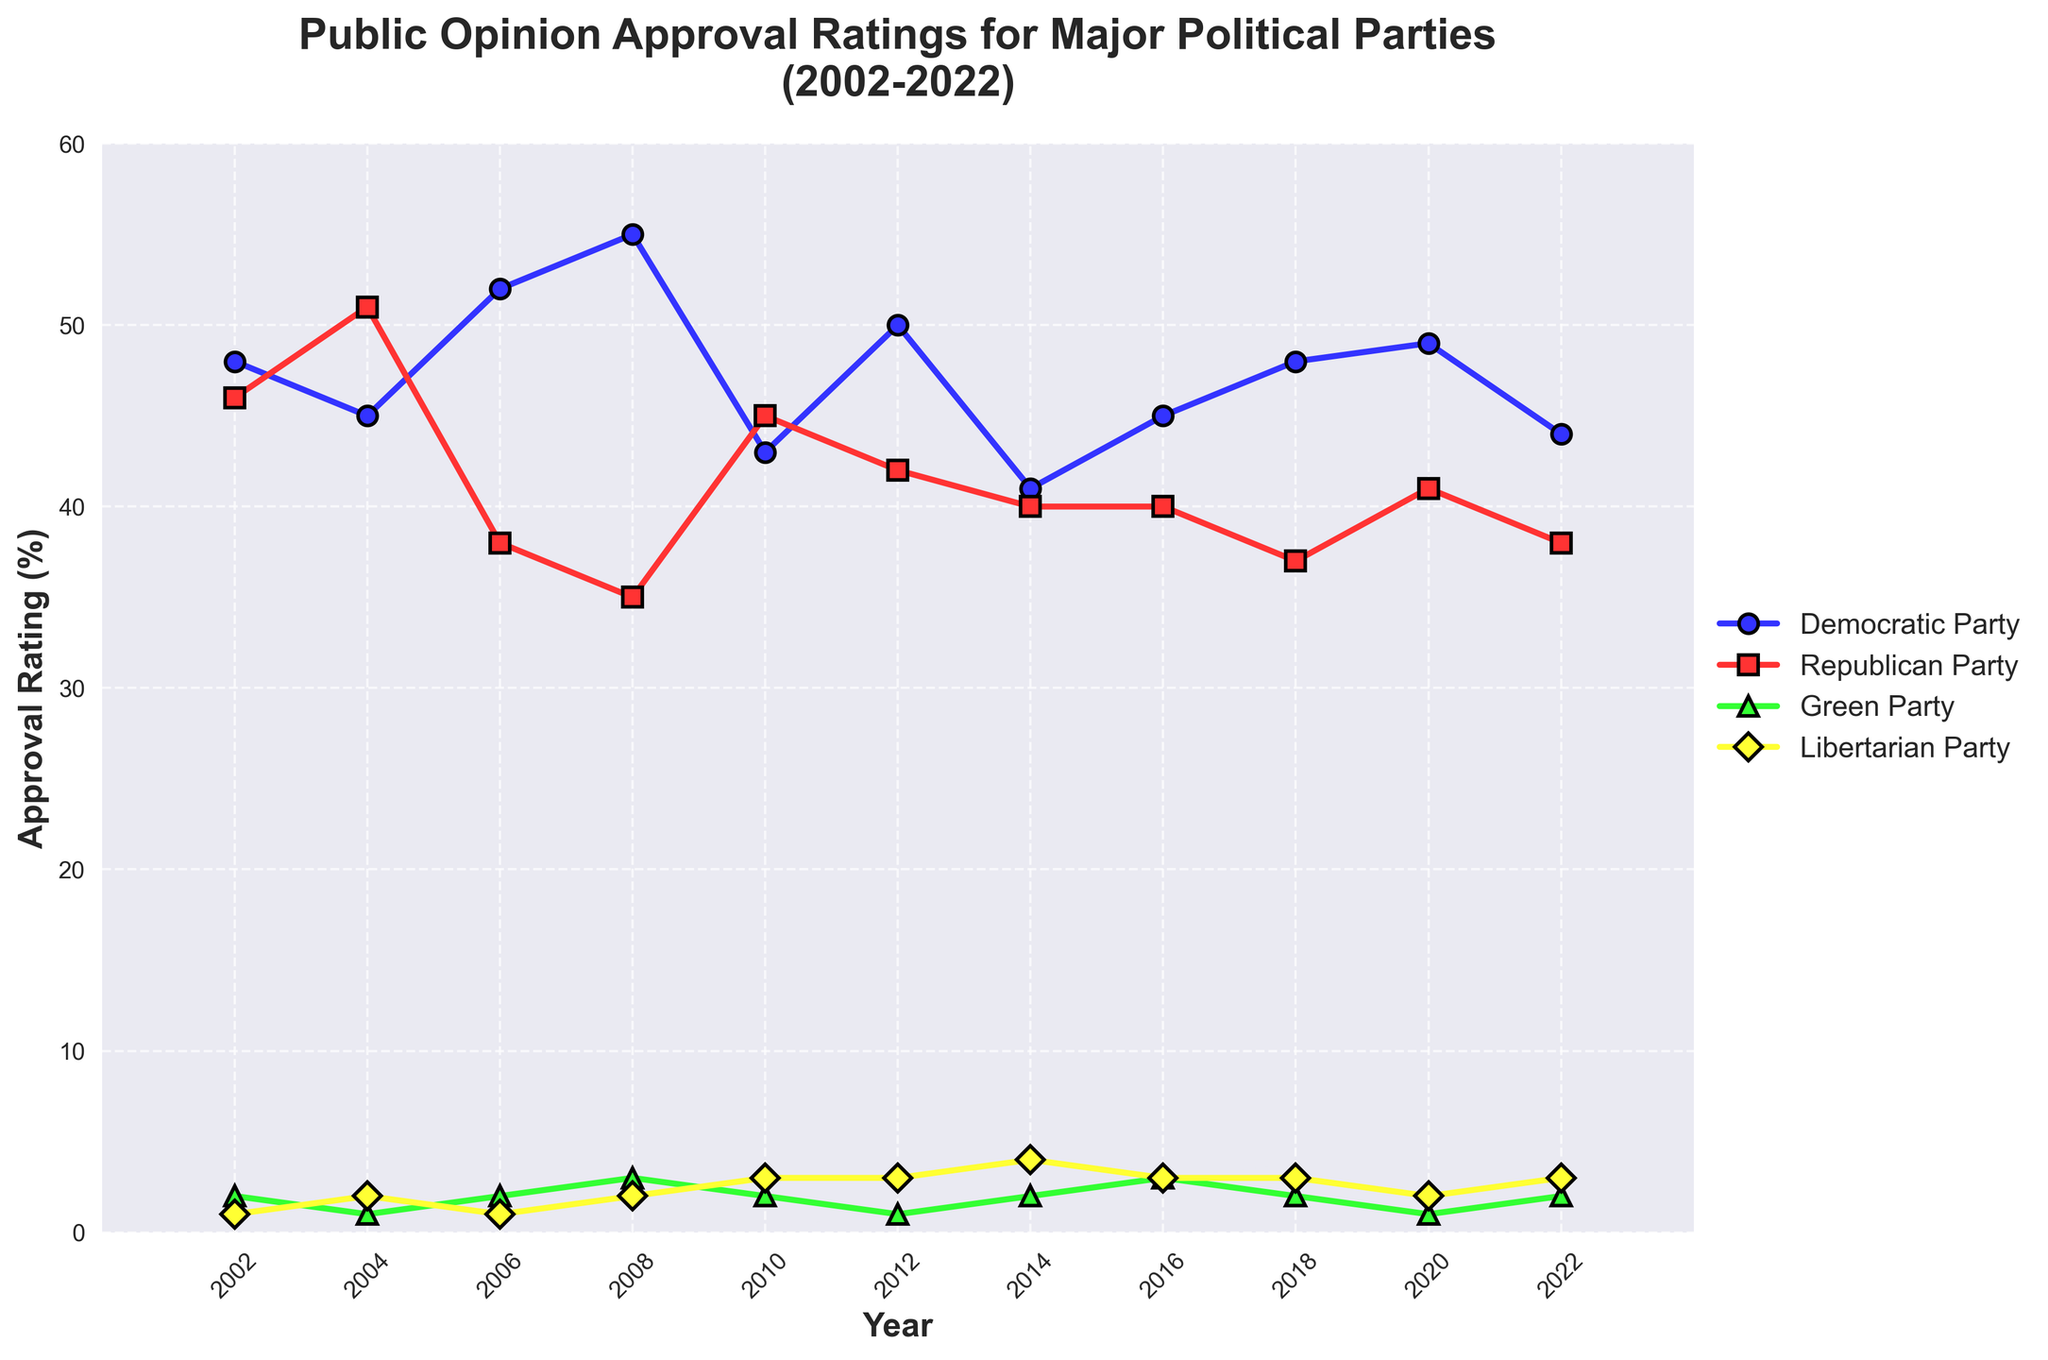What year did the Democratic Party have the highest approval rating? To find this, locate the peak point of the blue line (representing the Democratic Party) on the chart and note the corresponding year.
Answer: 2008 During which year did the Republican Party have a higher approval rating than the Democratic Party? Look for points where the red line (Republican Party) is above the blue line (Democratic Party) and note the corresponding year(s).
Answer: 2004, 2010 In which year were the approval ratings of the Green Party and the Libertarian Party equal? Compare the green and yellow lines and check for the point(s) where they intersect, indicating equal approval ratings.
Answer: 2016 What is the average approval rating of the Democratic Party over the entire period? Sum the Democratic Party approval ratings from 2002 to 2022. Then divide by the number of years (11). (48 + 45 + 52 + 55 + 43 + 50 + 41 + 45 + 48 + 49 + 44)/11.
Answer: 46.0 In which year did the Green Party achieve its highest approval rating? Identify the peak point of the green line representing the Green Party and note the corresponding year.
Answer: 2008, 2016 By how many percentage points did the approval rating of the Republican Party decrease from 2004 to 2006? Subtract the Republican Party approval rating in 2006 (38) from its rating in 2004 (51).
Answer: 13 Compare the approval ratings of the Democratic and Republican Parties in 2018. Which party had a higher rating and by how many percentage points? Check the 2018 ratings for both parties: Democratic Party (48), Republican Party (37). Subtract the Republican Party rating from the Democratic Party rating.
Answer: Democratic Party by 11 percentage points What was the trend in the approval rating for the Libertarian Party from 2010 to 2014? Observe the yellow line representing the Libertarian Party over the years 2010 to 2014: 3% in 2010, 3% in 2012, and 4% in 2014. Describe the trend.
Answer: Increasing Which party had an approval rating of 2% in multiple years, and which years were these? Identify the lines that touch the 2% mark multiple times and note the parties and years. The Green Party (2002, 2006, 2010, 2018, 2022) and the Libertarian Party (2002, 2006).
Answer: Green Party (2002, 2006, 2010, 2018, 2022), Libertarian Party (2002, 2006) How did the Democratic Party's approval rating change from 2010 to 2012? Subtract the Democratic Party's rating in 2010 (43) from its rating in 2012 (50).
Answer: Increased by 7 